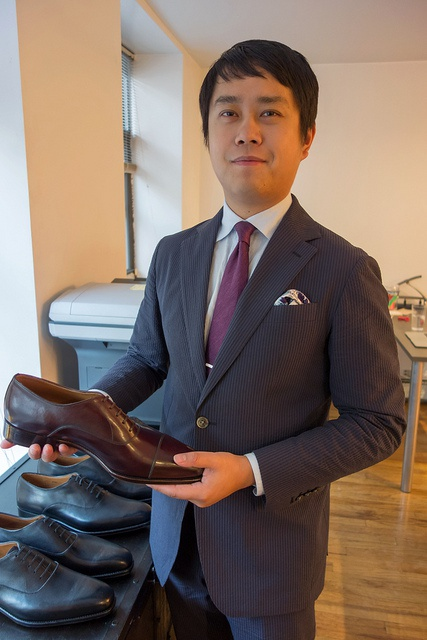Describe the objects in this image and their specific colors. I can see people in lightgray, black, maroon, and gray tones and tie in lightgray, purple, and black tones in this image. 